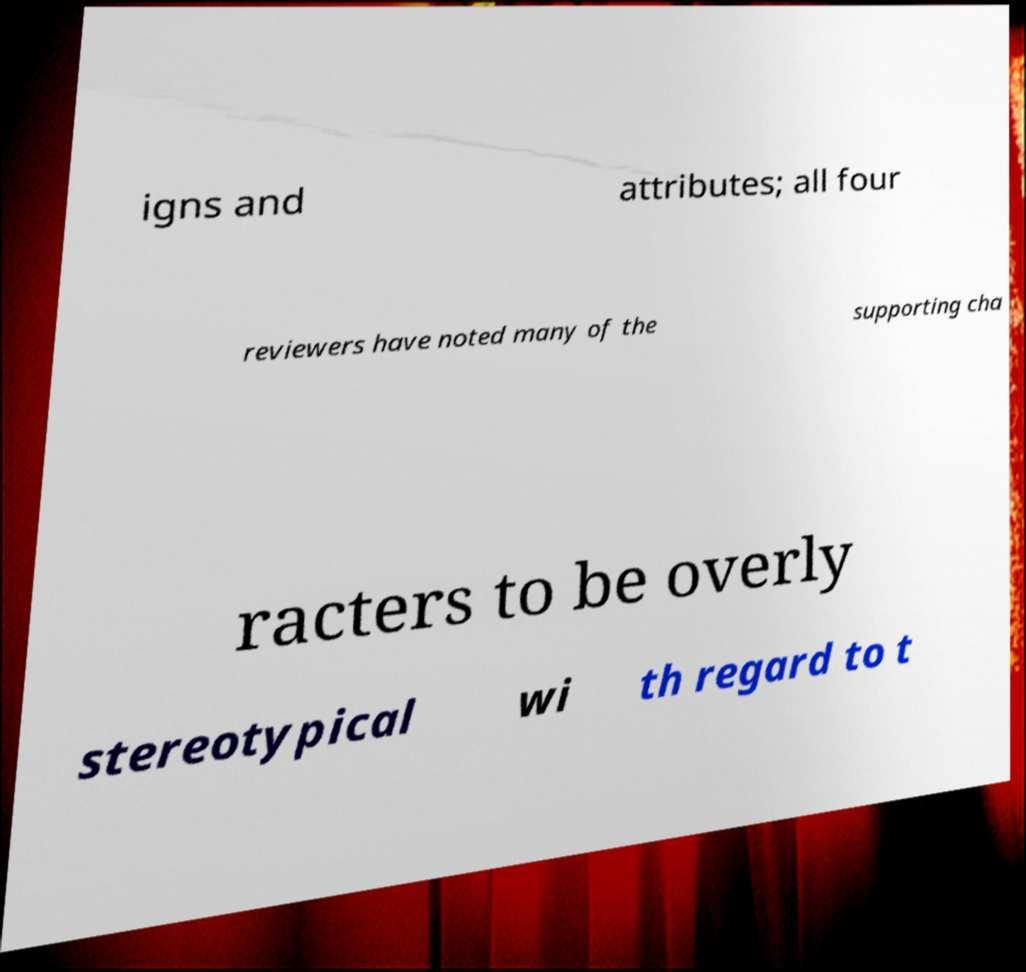Can you read and provide the text displayed in the image?This photo seems to have some interesting text. Can you extract and type it out for me? igns and attributes; all four reviewers have noted many of the supporting cha racters to be overly stereotypical wi th regard to t 